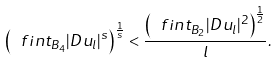Convert formula to latex. <formula><loc_0><loc_0><loc_500><loc_500>\left ( \ f i n t _ { B _ { 4 } } | D u _ { l } | ^ { s } \right ) ^ { \frac { 1 } { s } } < \frac { \left ( \ f i n t _ { B _ { 2 } } | D u _ { l } | ^ { 2 } \right ) ^ { \frac { 1 } { 2 } } } { l } .</formula> 